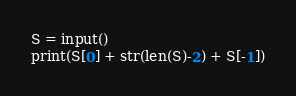Convert code to text. <code><loc_0><loc_0><loc_500><loc_500><_Python_>S = input()
print(S[0] + str(len(S)-2) + S[-1])

</code> 